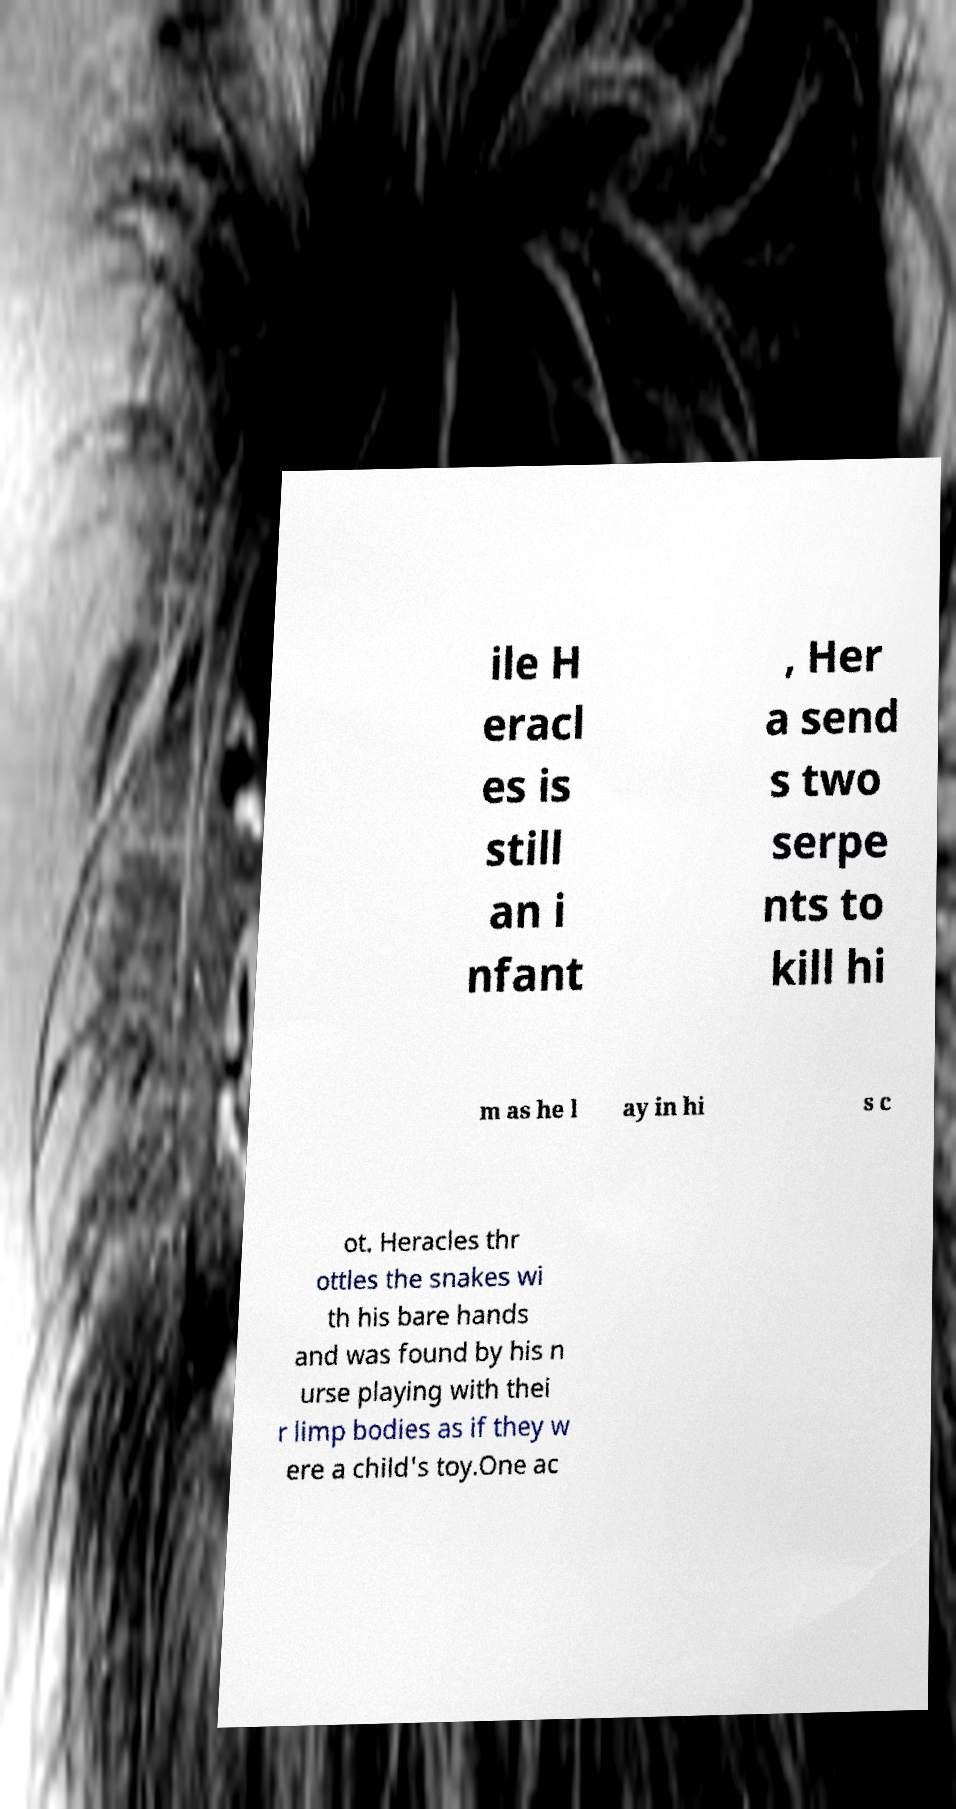Could you extract and type out the text from this image? ile H eracl es is still an i nfant , Her a send s two serpe nts to kill hi m as he l ay in hi s c ot. Heracles thr ottles the snakes wi th his bare hands and was found by his n urse playing with thei r limp bodies as if they w ere a child's toy.One ac 